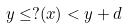Convert formula to latex. <formula><loc_0><loc_0><loc_500><loc_500>y \leq ? ( x ) < y + d</formula> 